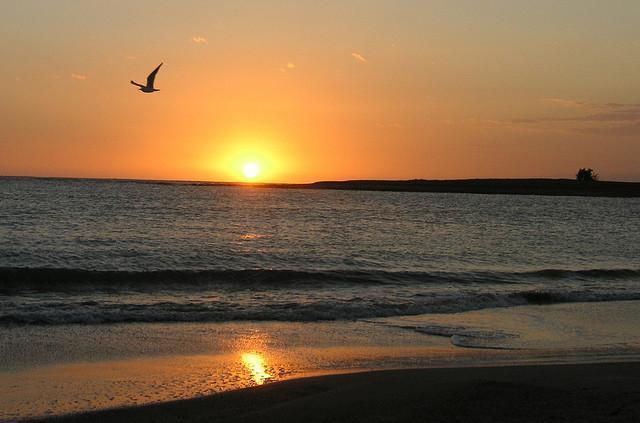How many animals are visible?
Give a very brief answer. 1. How many people are in this photo?
Give a very brief answer. 0. 